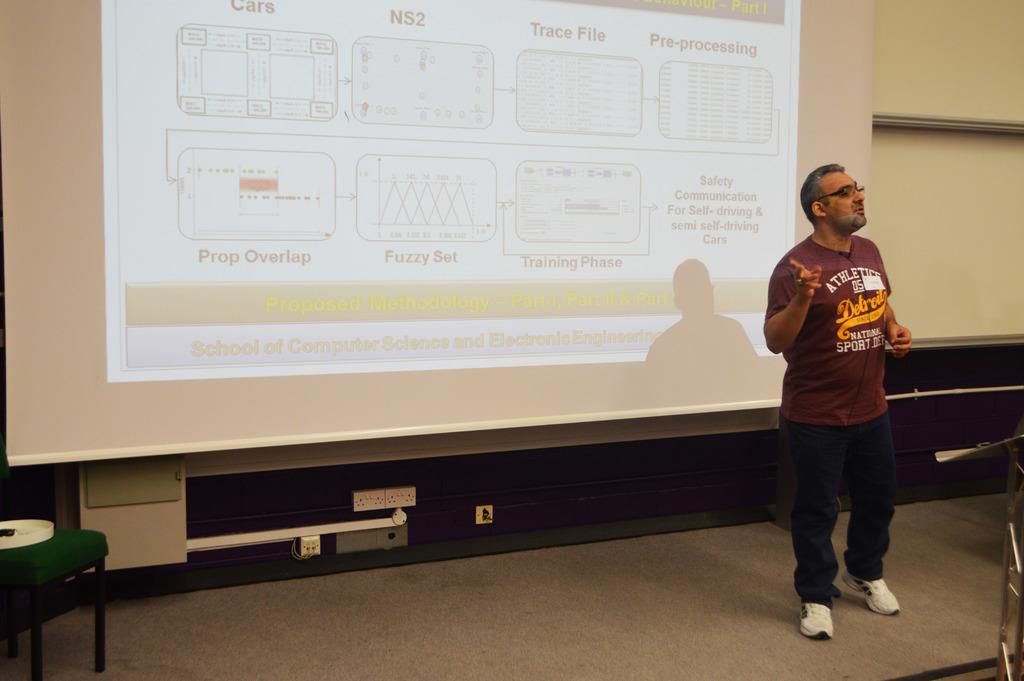What is the name of the slide being shown?
Make the answer very short. Unanswerable. 